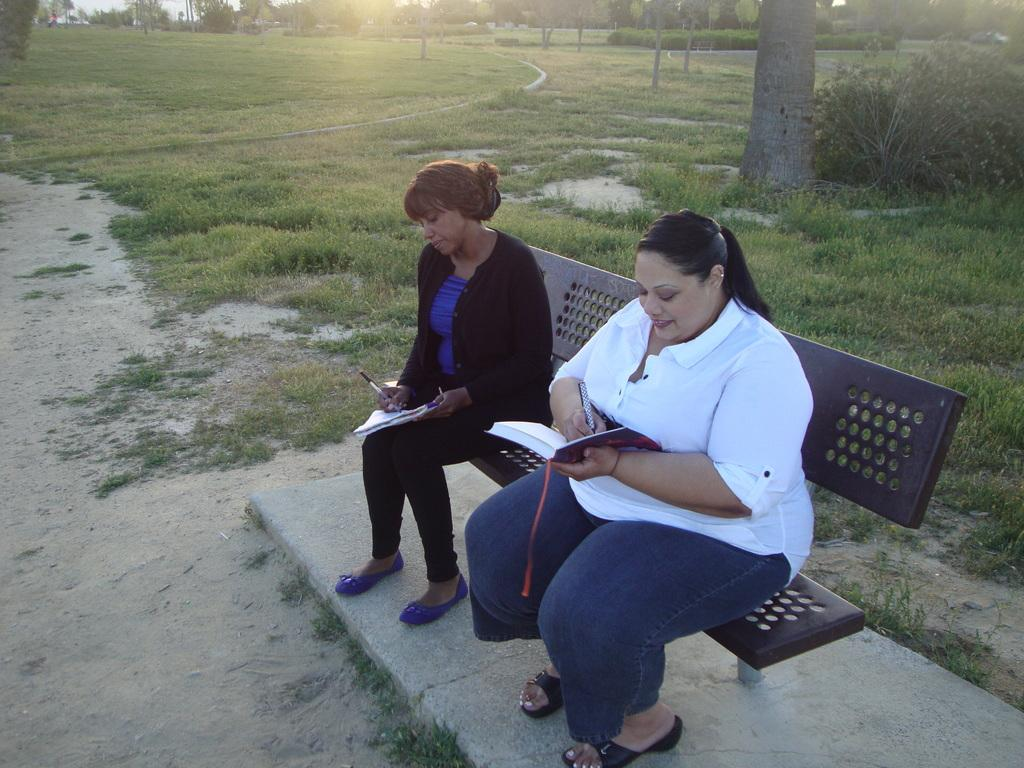What are the women in the image doing? The two women are sitting on a bench in the image. What are the women holding in their hands? The women are holding a book and a pen. What can be seen in the background of the image? There are trees and shrubs in the background of the image. What type of bomb can be seen in the image? There is no bomb present in the image. Are the women playing with any balls in the image? There are no balls present in the image. 